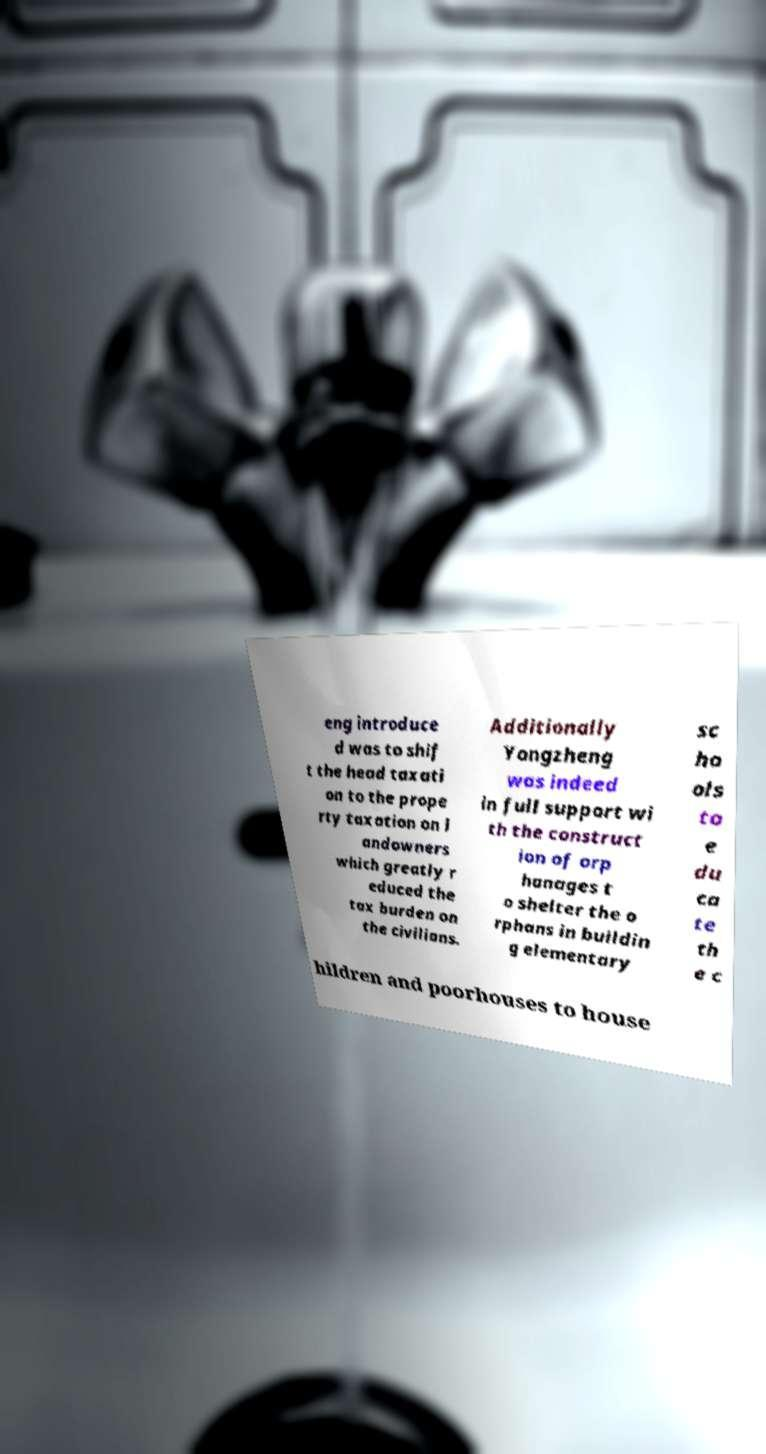I need the written content from this picture converted into text. Can you do that? eng introduce d was to shif t the head taxati on to the prope rty taxation on l andowners which greatly r educed the tax burden on the civilians. Additionally Yongzheng was indeed in full support wi th the construct ion of orp hanages t o shelter the o rphans in buildin g elementary sc ho ols to e du ca te th e c hildren and poorhouses to house 